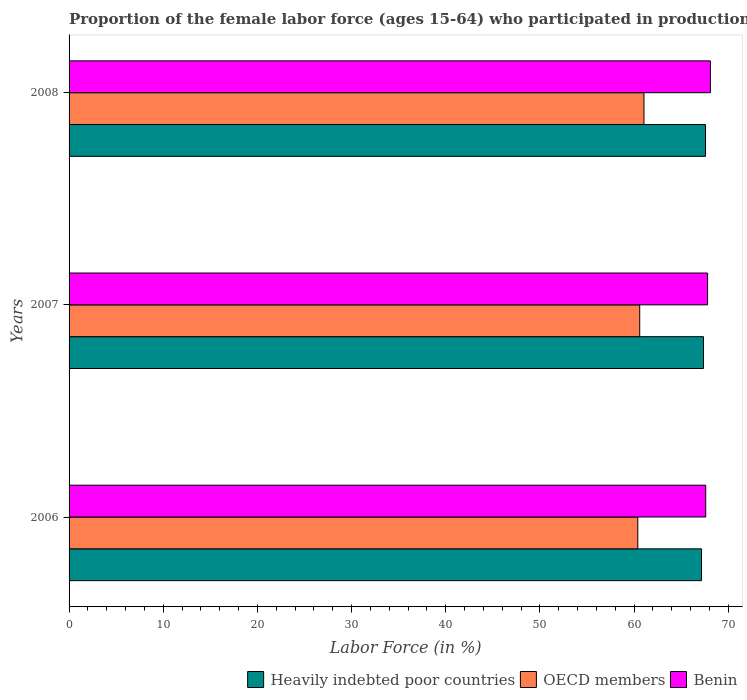How many different coloured bars are there?
Offer a terse response. 3. How many groups of bars are there?
Make the answer very short. 3. Are the number of bars per tick equal to the number of legend labels?
Make the answer very short. Yes. Are the number of bars on each tick of the Y-axis equal?
Offer a terse response. Yes. How many bars are there on the 3rd tick from the top?
Offer a terse response. 3. What is the label of the 3rd group of bars from the top?
Provide a succinct answer. 2006. In how many cases, is the number of bars for a given year not equal to the number of legend labels?
Your response must be concise. 0. What is the proportion of the female labor force who participated in production in OECD members in 2008?
Offer a very short reply. 61.04. Across all years, what is the maximum proportion of the female labor force who participated in production in Heavily indebted poor countries?
Provide a succinct answer. 67.57. Across all years, what is the minimum proportion of the female labor force who participated in production in Heavily indebted poor countries?
Your answer should be compact. 67.15. In which year was the proportion of the female labor force who participated in production in Heavily indebted poor countries maximum?
Provide a succinct answer. 2008. In which year was the proportion of the female labor force who participated in production in Benin minimum?
Provide a succinct answer. 2006. What is the total proportion of the female labor force who participated in production in OECD members in the graph?
Your answer should be very brief. 182.02. What is the difference between the proportion of the female labor force who participated in production in Heavily indebted poor countries in 2007 and that in 2008?
Make the answer very short. -0.21. What is the difference between the proportion of the female labor force who participated in production in OECD members in 2008 and the proportion of the female labor force who participated in production in Benin in 2007?
Keep it short and to the point. -6.76. What is the average proportion of the female labor force who participated in production in Benin per year?
Provide a short and direct response. 67.83. In the year 2008, what is the difference between the proportion of the female labor force who participated in production in Benin and proportion of the female labor force who participated in production in OECD members?
Make the answer very short. 7.06. In how many years, is the proportion of the female labor force who participated in production in Benin greater than 16 %?
Keep it short and to the point. 3. What is the ratio of the proportion of the female labor force who participated in production in Heavily indebted poor countries in 2006 to that in 2007?
Give a very brief answer. 1. What is the difference between the highest and the second highest proportion of the female labor force who participated in production in OECD members?
Your answer should be compact. 0.45. What is the difference between the highest and the lowest proportion of the female labor force who participated in production in OECD members?
Make the answer very short. 0.65. Is the sum of the proportion of the female labor force who participated in production in OECD members in 2006 and 2008 greater than the maximum proportion of the female labor force who participated in production in Benin across all years?
Keep it short and to the point. Yes. What does the 1st bar from the top in 2007 represents?
Keep it short and to the point. Benin. What does the 2nd bar from the bottom in 2008 represents?
Offer a very short reply. OECD members. Is it the case that in every year, the sum of the proportion of the female labor force who participated in production in Benin and proportion of the female labor force who participated in production in Heavily indebted poor countries is greater than the proportion of the female labor force who participated in production in OECD members?
Give a very brief answer. Yes. Are all the bars in the graph horizontal?
Offer a terse response. Yes. How many years are there in the graph?
Give a very brief answer. 3. What is the difference between two consecutive major ticks on the X-axis?
Make the answer very short. 10. Are the values on the major ticks of X-axis written in scientific E-notation?
Offer a terse response. No. How are the legend labels stacked?
Provide a succinct answer. Horizontal. What is the title of the graph?
Your answer should be very brief. Proportion of the female labor force (ages 15-64) who participated in production. What is the label or title of the X-axis?
Your answer should be very brief. Labor Force (in %). What is the Labor Force (in %) in Heavily indebted poor countries in 2006?
Your response must be concise. 67.15. What is the Labor Force (in %) in OECD members in 2006?
Ensure brevity in your answer.  60.39. What is the Labor Force (in %) of Benin in 2006?
Make the answer very short. 67.6. What is the Labor Force (in %) of Heavily indebted poor countries in 2007?
Offer a very short reply. 67.36. What is the Labor Force (in %) of OECD members in 2007?
Your answer should be compact. 60.59. What is the Labor Force (in %) in Benin in 2007?
Your answer should be compact. 67.8. What is the Labor Force (in %) in Heavily indebted poor countries in 2008?
Ensure brevity in your answer.  67.57. What is the Labor Force (in %) of OECD members in 2008?
Offer a terse response. 61.04. What is the Labor Force (in %) of Benin in 2008?
Keep it short and to the point. 68.1. Across all years, what is the maximum Labor Force (in %) in Heavily indebted poor countries?
Keep it short and to the point. 67.57. Across all years, what is the maximum Labor Force (in %) in OECD members?
Provide a short and direct response. 61.04. Across all years, what is the maximum Labor Force (in %) of Benin?
Ensure brevity in your answer.  68.1. Across all years, what is the minimum Labor Force (in %) of Heavily indebted poor countries?
Provide a succinct answer. 67.15. Across all years, what is the minimum Labor Force (in %) in OECD members?
Ensure brevity in your answer.  60.39. Across all years, what is the minimum Labor Force (in %) in Benin?
Make the answer very short. 67.6. What is the total Labor Force (in %) of Heavily indebted poor countries in the graph?
Offer a very short reply. 202.09. What is the total Labor Force (in %) of OECD members in the graph?
Provide a succinct answer. 182.02. What is the total Labor Force (in %) in Benin in the graph?
Keep it short and to the point. 203.5. What is the difference between the Labor Force (in %) of Heavily indebted poor countries in 2006 and that in 2007?
Ensure brevity in your answer.  -0.21. What is the difference between the Labor Force (in %) in OECD members in 2006 and that in 2007?
Offer a terse response. -0.2. What is the difference between the Labor Force (in %) of Heavily indebted poor countries in 2006 and that in 2008?
Give a very brief answer. -0.42. What is the difference between the Labor Force (in %) of OECD members in 2006 and that in 2008?
Provide a succinct answer. -0.65. What is the difference between the Labor Force (in %) in Benin in 2006 and that in 2008?
Keep it short and to the point. -0.5. What is the difference between the Labor Force (in %) of Heavily indebted poor countries in 2007 and that in 2008?
Your answer should be compact. -0.21. What is the difference between the Labor Force (in %) of OECD members in 2007 and that in 2008?
Your answer should be compact. -0.45. What is the difference between the Labor Force (in %) of Heavily indebted poor countries in 2006 and the Labor Force (in %) of OECD members in 2007?
Keep it short and to the point. 6.56. What is the difference between the Labor Force (in %) in Heavily indebted poor countries in 2006 and the Labor Force (in %) in Benin in 2007?
Provide a succinct answer. -0.65. What is the difference between the Labor Force (in %) in OECD members in 2006 and the Labor Force (in %) in Benin in 2007?
Provide a short and direct response. -7.41. What is the difference between the Labor Force (in %) in Heavily indebted poor countries in 2006 and the Labor Force (in %) in OECD members in 2008?
Keep it short and to the point. 6.11. What is the difference between the Labor Force (in %) in Heavily indebted poor countries in 2006 and the Labor Force (in %) in Benin in 2008?
Keep it short and to the point. -0.95. What is the difference between the Labor Force (in %) of OECD members in 2006 and the Labor Force (in %) of Benin in 2008?
Offer a terse response. -7.71. What is the difference between the Labor Force (in %) in Heavily indebted poor countries in 2007 and the Labor Force (in %) in OECD members in 2008?
Offer a very short reply. 6.32. What is the difference between the Labor Force (in %) of Heavily indebted poor countries in 2007 and the Labor Force (in %) of Benin in 2008?
Your answer should be very brief. -0.74. What is the difference between the Labor Force (in %) of OECD members in 2007 and the Labor Force (in %) of Benin in 2008?
Keep it short and to the point. -7.51. What is the average Labor Force (in %) of Heavily indebted poor countries per year?
Your answer should be very brief. 67.36. What is the average Labor Force (in %) of OECD members per year?
Your answer should be compact. 60.67. What is the average Labor Force (in %) in Benin per year?
Offer a very short reply. 67.83. In the year 2006, what is the difference between the Labor Force (in %) in Heavily indebted poor countries and Labor Force (in %) in OECD members?
Ensure brevity in your answer.  6.77. In the year 2006, what is the difference between the Labor Force (in %) of Heavily indebted poor countries and Labor Force (in %) of Benin?
Your answer should be very brief. -0.45. In the year 2006, what is the difference between the Labor Force (in %) in OECD members and Labor Force (in %) in Benin?
Your answer should be very brief. -7.21. In the year 2007, what is the difference between the Labor Force (in %) of Heavily indebted poor countries and Labor Force (in %) of OECD members?
Ensure brevity in your answer.  6.77. In the year 2007, what is the difference between the Labor Force (in %) of Heavily indebted poor countries and Labor Force (in %) of Benin?
Your response must be concise. -0.44. In the year 2007, what is the difference between the Labor Force (in %) of OECD members and Labor Force (in %) of Benin?
Make the answer very short. -7.21. In the year 2008, what is the difference between the Labor Force (in %) of Heavily indebted poor countries and Labor Force (in %) of OECD members?
Ensure brevity in your answer.  6.53. In the year 2008, what is the difference between the Labor Force (in %) in Heavily indebted poor countries and Labor Force (in %) in Benin?
Offer a terse response. -0.53. In the year 2008, what is the difference between the Labor Force (in %) of OECD members and Labor Force (in %) of Benin?
Keep it short and to the point. -7.06. What is the ratio of the Labor Force (in %) of Heavily indebted poor countries in 2006 to that in 2007?
Your answer should be compact. 1. What is the ratio of the Labor Force (in %) of OECD members in 2006 to that in 2008?
Offer a terse response. 0.99. What is the ratio of the Labor Force (in %) in Heavily indebted poor countries in 2007 to that in 2008?
Offer a very short reply. 1. What is the ratio of the Labor Force (in %) of OECD members in 2007 to that in 2008?
Your answer should be compact. 0.99. What is the ratio of the Labor Force (in %) in Benin in 2007 to that in 2008?
Make the answer very short. 1. What is the difference between the highest and the second highest Labor Force (in %) of Heavily indebted poor countries?
Make the answer very short. 0.21. What is the difference between the highest and the second highest Labor Force (in %) of OECD members?
Offer a very short reply. 0.45. What is the difference between the highest and the second highest Labor Force (in %) in Benin?
Keep it short and to the point. 0.3. What is the difference between the highest and the lowest Labor Force (in %) in Heavily indebted poor countries?
Your answer should be very brief. 0.42. What is the difference between the highest and the lowest Labor Force (in %) in OECD members?
Ensure brevity in your answer.  0.65. What is the difference between the highest and the lowest Labor Force (in %) of Benin?
Give a very brief answer. 0.5. 